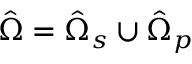<formula> <loc_0><loc_0><loc_500><loc_500>\hat { \Omega } = \hat { \Omega } _ { s } \cup \hat { \Omega } _ { p }</formula> 